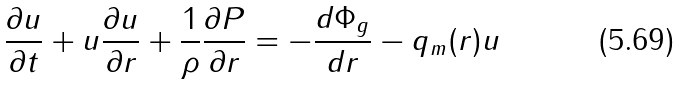Convert formula to latex. <formula><loc_0><loc_0><loc_500><loc_500>\frac { \partial u } { \partial t } + u \frac { \partial u } { \partial r } + \frac { 1 } { \rho } \frac { \partial P } { \partial r } = - \frac { d \Phi _ { g } } { d r } - q _ { m } ( r ) u</formula> 